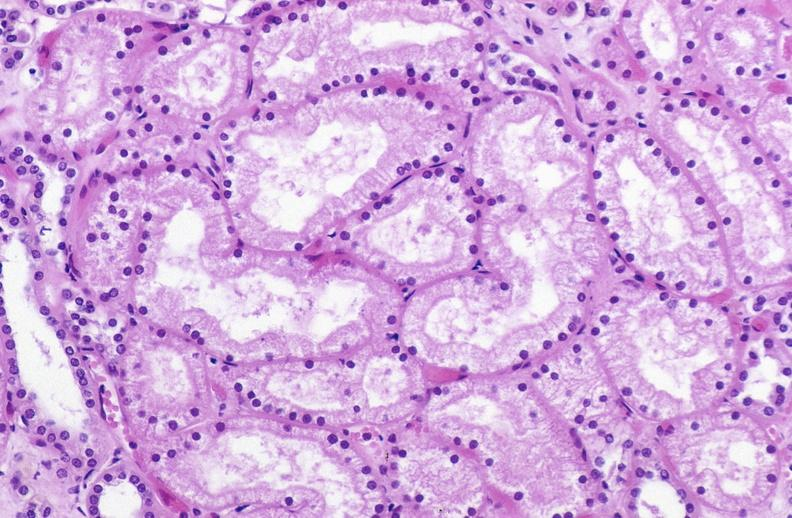does this image show atn acute tubular necrosis?
Answer the question using a single word or phrase. Yes 